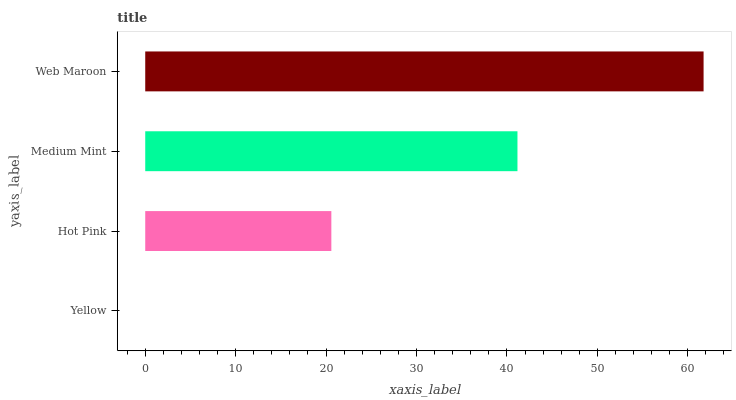Is Yellow the minimum?
Answer yes or no. Yes. Is Web Maroon the maximum?
Answer yes or no. Yes. Is Hot Pink the minimum?
Answer yes or no. No. Is Hot Pink the maximum?
Answer yes or no. No. Is Hot Pink greater than Yellow?
Answer yes or no. Yes. Is Yellow less than Hot Pink?
Answer yes or no. Yes. Is Yellow greater than Hot Pink?
Answer yes or no. No. Is Hot Pink less than Yellow?
Answer yes or no. No. Is Medium Mint the high median?
Answer yes or no. Yes. Is Hot Pink the low median?
Answer yes or no. Yes. Is Yellow the high median?
Answer yes or no. No. Is Yellow the low median?
Answer yes or no. No. 